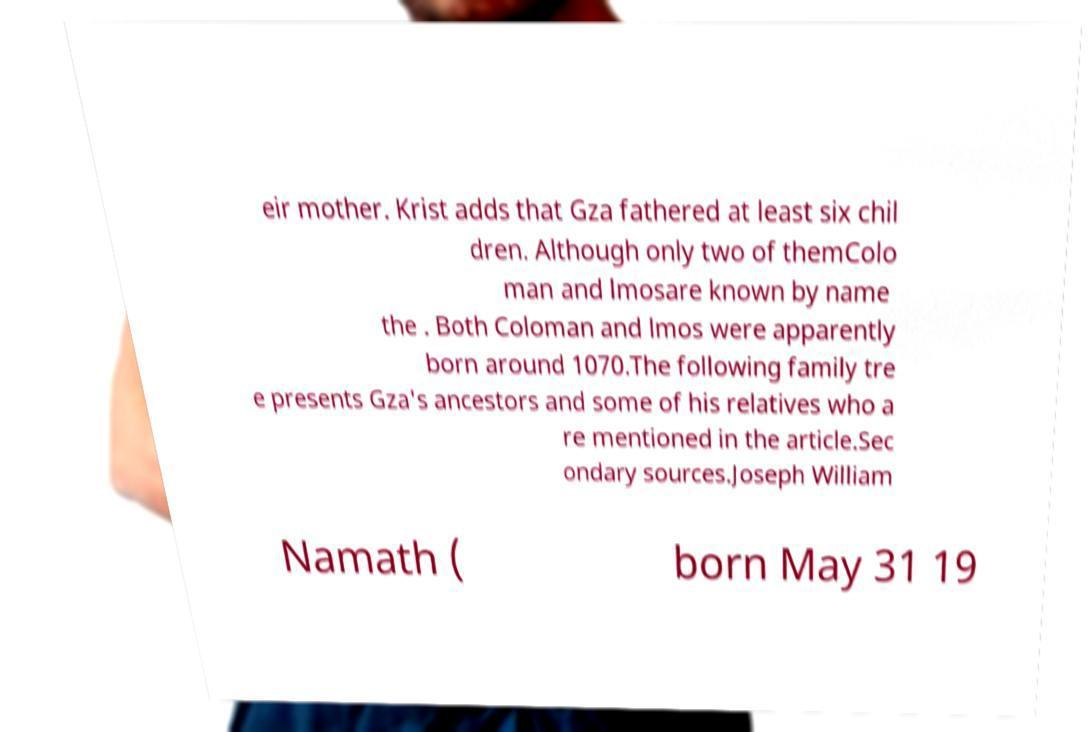I need the written content from this picture converted into text. Can you do that? eir mother. Krist adds that Gza fathered at least six chil dren. Although only two of themColo man and lmosare known by name the . Both Coloman and lmos were apparently born around 1070.The following family tre e presents Gza's ancestors and some of his relatives who a re mentioned in the article.Sec ondary sources.Joseph William Namath ( born May 31 19 